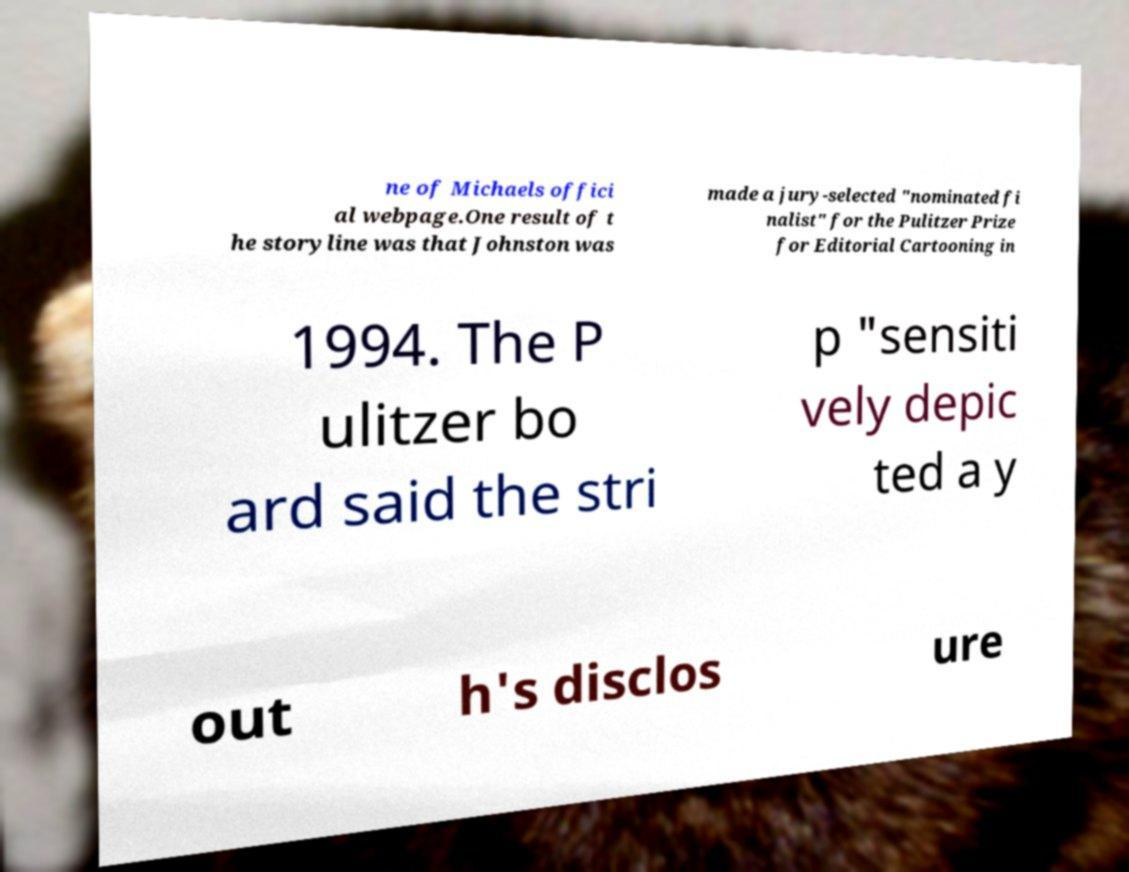Could you assist in decoding the text presented in this image and type it out clearly? ne of Michaels offici al webpage.One result of t he storyline was that Johnston was made a jury-selected "nominated fi nalist" for the Pulitzer Prize for Editorial Cartooning in 1994. The P ulitzer bo ard said the stri p "sensiti vely depic ted a y out h's disclos ure 